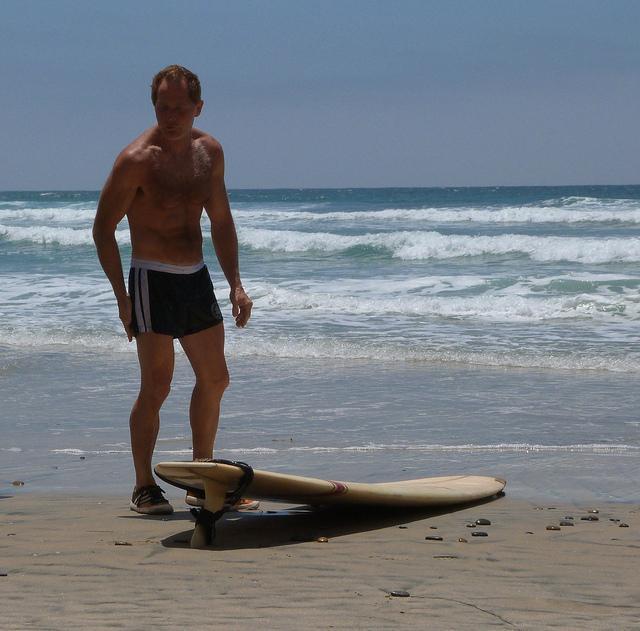How many fins does the board have?
Give a very brief answer. 1. How many fins are on the board?
Give a very brief answer. 1. 